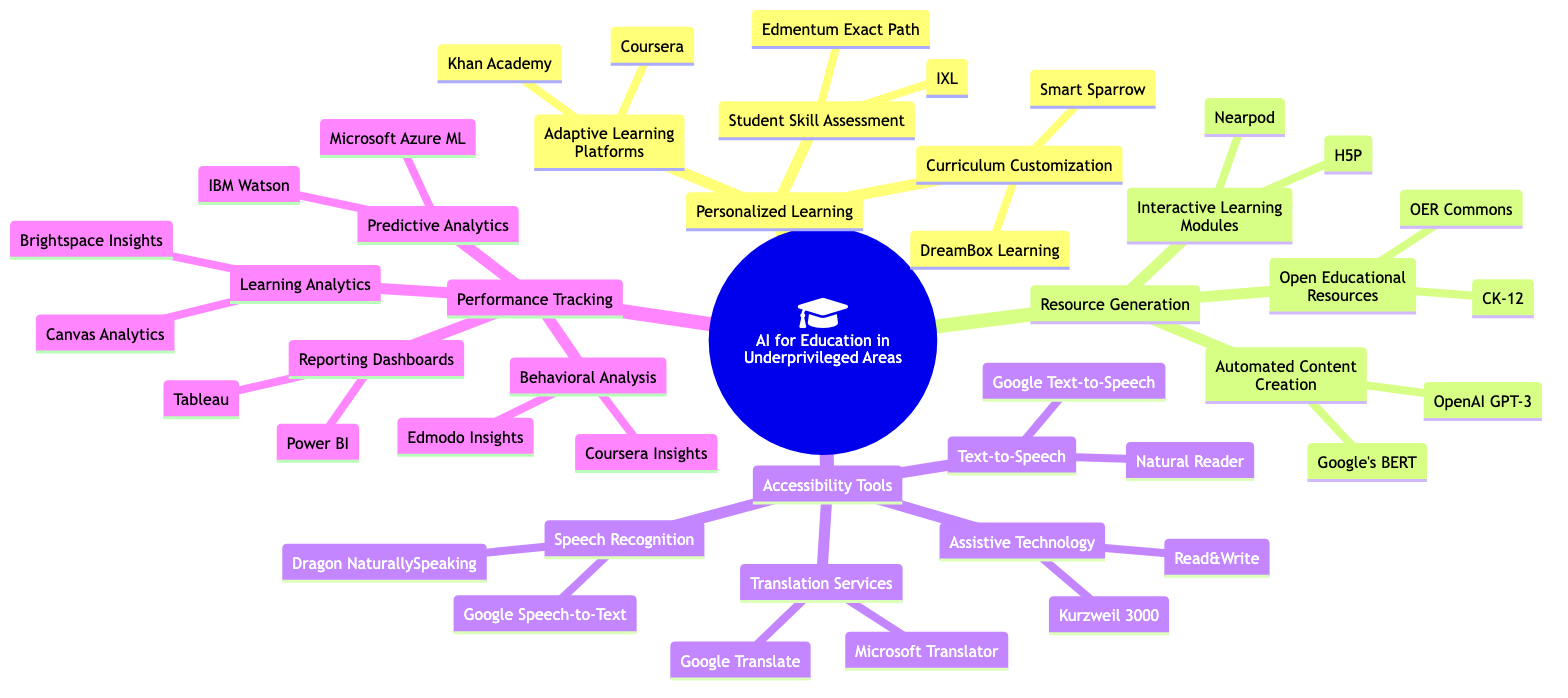What is one example of an adaptive learning platform? The diagram lists "Khan Academy" and "Coursera" as examples under the "Adaptive Learning Platforms" component of "Personalized Learning."
Answer: Khan Academy How many accessibility tools are listed in the diagram? Under the "Accessibility Tools" category, there are four main subcategories: Text-to-Speech, Speech Recognition, Translation Services, and Assistive Technology, each listing various tools, thus totaling four main categories.
Answer: 4 Which resource generation tool is mentioned for automated content creation? The diagram specifies "OpenAI GPT-3" and "Google's BERT" under "Automated Content Creation" in the "Resource Generation" section, indicating both are examples of tools used for this purpose.
Answer: OpenAI GPT-3 What type of analytics is shown under Performance Tracking that involves predicting outcomes? The "Predictive Analytics" section under "Performance Tracking" specifies tools such as "IBM Watson" and "Microsoft Azure Machine Learning" which focus on predicting outcomes in educational performance.
Answer: Predictive Analytics Name a text-to-speech tool mentioned in the diagram. The diagram identifies "Natural Reader" and "Google Text-to-Speech" under the "Text-to-Speech" subcategory of "Accessibility Tools," thus referencing specific tools that serve this function.
Answer: Natural Reader How is "Curriculum Customization" categorized in this diagram? The term "Curriculum Customization" is listed as a part of the broader "Personalized Learning" category, indicating its role in tailoring educational content to individual needs.
Answer: Personalized Learning Which reporting dashboard tools are highlighted in the diagram? Under "Reporting Dashboards," the diagram explicitly lists "Tableau" and "Power BI" as examples, showing how these tools are utilized for performance tracking and analytics in education.
Answer: Tableau What are the names of two open educational resource platforms? The "Open Educational Resources (OER)" subcategory under "Resource Generation" mentions "OER Commons" and "CK-12" as exemplars, indicating specific platforms where educational resources can be accessed.
Answer: OER Commons Which accessibility tool is designed for speech recognition? The diagram identifies tools specifically for speech recognition, which include "Google Speech-to-Text" and "Dragon NaturallySpeaking," categorizing them under the "Speech Recognition" section of "Accessibility Tools."
Answer: Google Speech-to-Text 